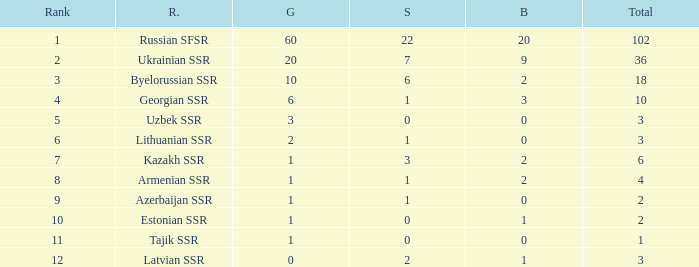Can you give me this table as a dict? {'header': ['Rank', 'R.', 'G', 'S', 'B', 'Total'], 'rows': [['1', 'Russian SFSR', '60', '22', '20', '102'], ['2', 'Ukrainian SSR', '20', '7', '9', '36'], ['3', 'Byelorussian SSR', '10', '6', '2', '18'], ['4', 'Georgian SSR', '6', '1', '3', '10'], ['5', 'Uzbek SSR', '3', '0', '0', '3'], ['6', 'Lithuanian SSR', '2', '1', '0', '3'], ['7', 'Kazakh SSR', '1', '3', '2', '6'], ['8', 'Armenian SSR', '1', '1', '2', '4'], ['9', 'Azerbaijan SSR', '1', '1', '0', '2'], ['10', 'Estonian SSR', '1', '0', '1', '2'], ['11', 'Tajik SSR', '1', '0', '0', '1'], ['12', 'Latvian SSR', '0', '2', '1', '3']]} What is the total number of bronzes associated with 1 silver, ranks under 6 and under 6 golds? None. 